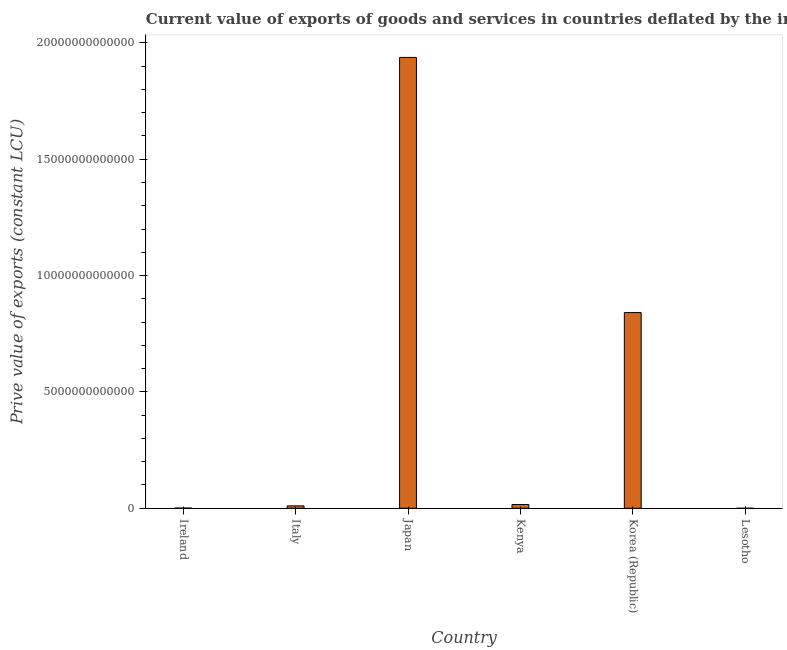Does the graph contain grids?
Your answer should be very brief. No. What is the title of the graph?
Offer a very short reply. Current value of exports of goods and services in countries deflated by the import price index. What is the label or title of the X-axis?
Make the answer very short. Country. What is the label or title of the Y-axis?
Make the answer very short. Prive value of exports (constant LCU). What is the price value of exports in Korea (Republic)?
Your response must be concise. 8.41e+12. Across all countries, what is the maximum price value of exports?
Your response must be concise. 1.94e+13. Across all countries, what is the minimum price value of exports?
Keep it short and to the point. 5.24e+08. In which country was the price value of exports minimum?
Make the answer very short. Lesotho. What is the sum of the price value of exports?
Your answer should be compact. 2.81e+13. What is the difference between the price value of exports in Kenya and Korea (Republic)?
Ensure brevity in your answer.  -8.25e+12. What is the average price value of exports per country?
Keep it short and to the point. 4.68e+12. What is the median price value of exports?
Offer a very short reply. 1.32e+11. In how many countries, is the price value of exports greater than 11000000000000 LCU?
Your answer should be very brief. 1. What is the ratio of the price value of exports in Italy to that in Lesotho?
Provide a succinct answer. 195.87. Is the price value of exports in Kenya less than that in Korea (Republic)?
Give a very brief answer. Yes. Is the difference between the price value of exports in Ireland and Italy greater than the difference between any two countries?
Make the answer very short. No. What is the difference between the highest and the second highest price value of exports?
Your answer should be very brief. 1.10e+13. What is the difference between the highest and the lowest price value of exports?
Provide a succinct answer. 1.94e+13. How many bars are there?
Make the answer very short. 6. Are all the bars in the graph horizontal?
Your response must be concise. No. What is the difference between two consecutive major ticks on the Y-axis?
Your answer should be compact. 5.00e+12. What is the Prive value of exports (constant LCU) in Ireland?
Make the answer very short. 7.83e+09. What is the Prive value of exports (constant LCU) of Italy?
Provide a short and direct response. 1.03e+11. What is the Prive value of exports (constant LCU) of Japan?
Your answer should be very brief. 1.94e+13. What is the Prive value of exports (constant LCU) in Kenya?
Your answer should be compact. 1.62e+11. What is the Prive value of exports (constant LCU) in Korea (Republic)?
Provide a short and direct response. 8.41e+12. What is the Prive value of exports (constant LCU) of Lesotho?
Give a very brief answer. 5.24e+08. What is the difference between the Prive value of exports (constant LCU) in Ireland and Italy?
Ensure brevity in your answer.  -9.49e+1. What is the difference between the Prive value of exports (constant LCU) in Ireland and Japan?
Give a very brief answer. -1.94e+13. What is the difference between the Prive value of exports (constant LCU) in Ireland and Kenya?
Keep it short and to the point. -1.54e+11. What is the difference between the Prive value of exports (constant LCU) in Ireland and Korea (Republic)?
Provide a short and direct response. -8.40e+12. What is the difference between the Prive value of exports (constant LCU) in Ireland and Lesotho?
Give a very brief answer. 7.31e+09. What is the difference between the Prive value of exports (constant LCU) in Italy and Japan?
Provide a short and direct response. -1.93e+13. What is the difference between the Prive value of exports (constant LCU) in Italy and Kenya?
Provide a short and direct response. -5.93e+1. What is the difference between the Prive value of exports (constant LCU) in Italy and Korea (Republic)?
Offer a very short reply. -8.31e+12. What is the difference between the Prive value of exports (constant LCU) in Italy and Lesotho?
Keep it short and to the point. 1.02e+11. What is the difference between the Prive value of exports (constant LCU) in Japan and Kenya?
Keep it short and to the point. 1.92e+13. What is the difference between the Prive value of exports (constant LCU) in Japan and Korea (Republic)?
Your answer should be compact. 1.10e+13. What is the difference between the Prive value of exports (constant LCU) in Japan and Lesotho?
Your answer should be compact. 1.94e+13. What is the difference between the Prive value of exports (constant LCU) in Kenya and Korea (Republic)?
Give a very brief answer. -8.25e+12. What is the difference between the Prive value of exports (constant LCU) in Kenya and Lesotho?
Provide a succinct answer. 1.61e+11. What is the difference between the Prive value of exports (constant LCU) in Korea (Republic) and Lesotho?
Your answer should be very brief. 8.41e+12. What is the ratio of the Prive value of exports (constant LCU) in Ireland to that in Italy?
Offer a very short reply. 0.08. What is the ratio of the Prive value of exports (constant LCU) in Ireland to that in Japan?
Ensure brevity in your answer.  0. What is the ratio of the Prive value of exports (constant LCU) in Ireland to that in Kenya?
Provide a short and direct response. 0.05. What is the ratio of the Prive value of exports (constant LCU) in Ireland to that in Lesotho?
Ensure brevity in your answer.  14.94. What is the ratio of the Prive value of exports (constant LCU) in Italy to that in Japan?
Keep it short and to the point. 0.01. What is the ratio of the Prive value of exports (constant LCU) in Italy to that in Kenya?
Your answer should be compact. 0.63. What is the ratio of the Prive value of exports (constant LCU) in Italy to that in Korea (Republic)?
Offer a very short reply. 0.01. What is the ratio of the Prive value of exports (constant LCU) in Italy to that in Lesotho?
Your answer should be very brief. 195.87. What is the ratio of the Prive value of exports (constant LCU) in Japan to that in Kenya?
Your answer should be very brief. 119.61. What is the ratio of the Prive value of exports (constant LCU) in Japan to that in Korea (Republic)?
Provide a succinct answer. 2.3. What is the ratio of the Prive value of exports (constant LCU) in Japan to that in Lesotho?
Offer a very short reply. 3.70e+04. What is the ratio of the Prive value of exports (constant LCU) in Kenya to that in Korea (Republic)?
Your response must be concise. 0.02. What is the ratio of the Prive value of exports (constant LCU) in Kenya to that in Lesotho?
Ensure brevity in your answer.  308.94. What is the ratio of the Prive value of exports (constant LCU) in Korea (Republic) to that in Lesotho?
Make the answer very short. 1.60e+04. 